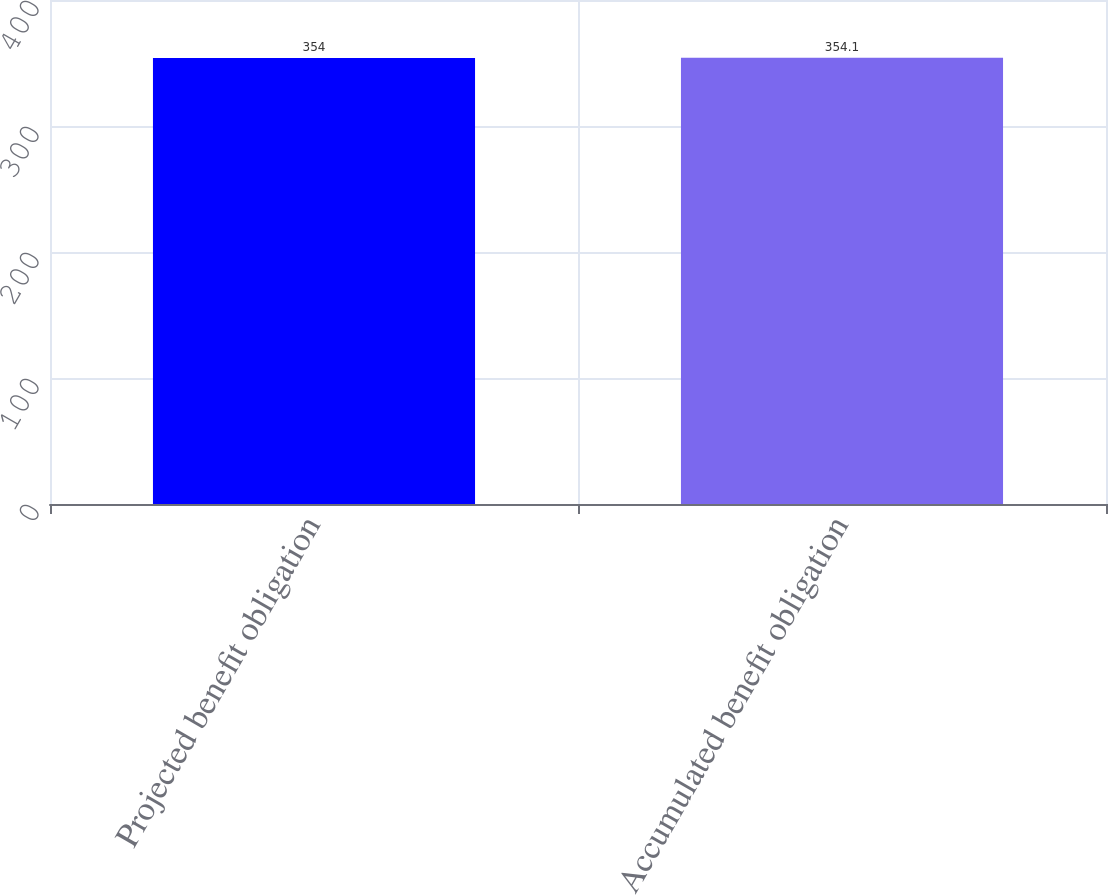Convert chart. <chart><loc_0><loc_0><loc_500><loc_500><bar_chart><fcel>Projected benefit obligation<fcel>Accumulated benefit obligation<nl><fcel>354<fcel>354.1<nl></chart> 